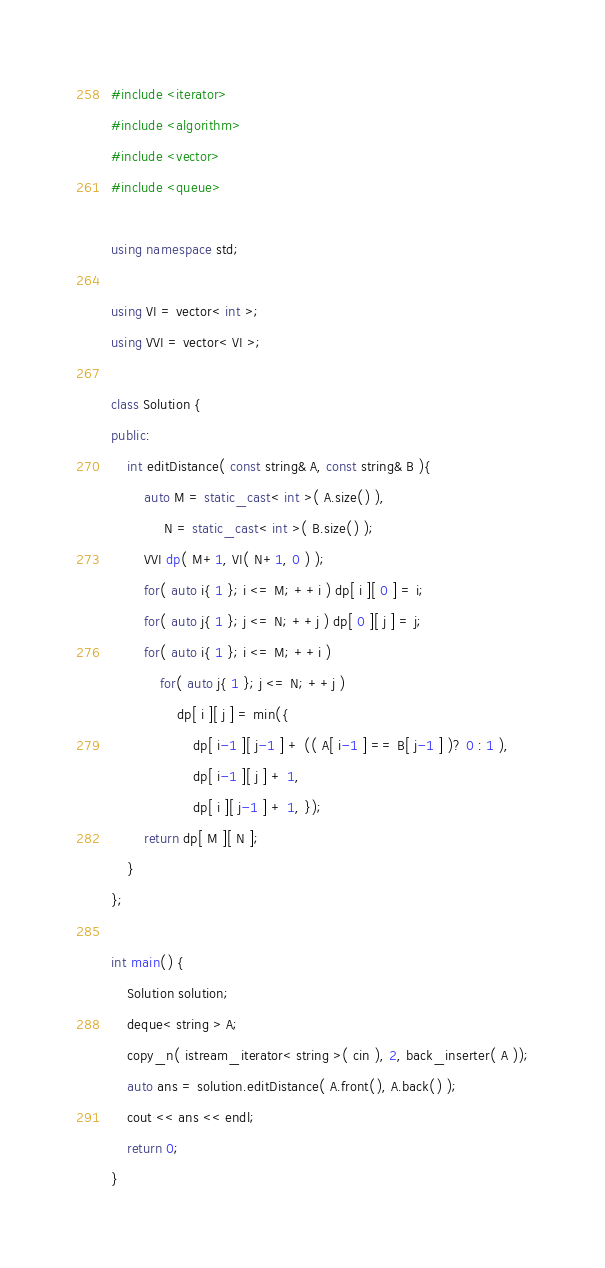<code> <loc_0><loc_0><loc_500><loc_500><_C++_>#include <iterator>
#include <algorithm>
#include <vector>
#include <queue>

using namespace std;

using VI = vector< int >;
using VVI = vector< VI >;

class Solution {
public:
    int editDistance( const string& A, const string& B ){
        auto M = static_cast< int >( A.size() ),
             N = static_cast< int >( B.size() );
        VVI dp( M+1, VI( N+1, 0 ) );
        for( auto i{ 1 }; i <= M; ++i ) dp[ i ][ 0 ] = i;
        for( auto j{ 1 }; j <= N; ++j ) dp[ 0 ][ j ] = j;
        for( auto i{ 1 }; i <= M; ++i )
            for( auto j{ 1 }; j <= N; ++j )
                dp[ i ][ j ] = min({
                    dp[ i-1 ][ j-1 ] + (( A[ i-1 ] == B[ j-1 ] )? 0 : 1 ),
                    dp[ i-1 ][ j ] + 1,
                    dp[ i ][ j-1 ] + 1, });
        return dp[ M ][ N ];
    }
};

int main() {
    Solution solution;
    deque< string > A;
    copy_n( istream_iterator< string >( cin ), 2, back_inserter( A ));
    auto ans = solution.editDistance( A.front(), A.back() );
    cout << ans << endl;
    return 0;
}
</code> 